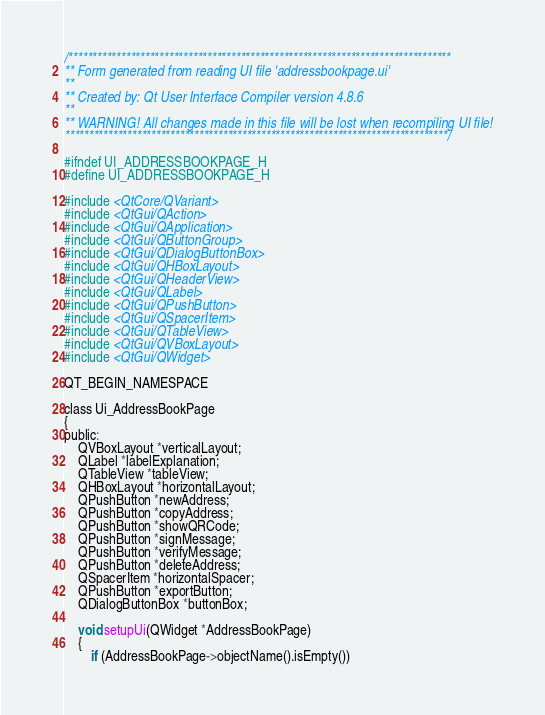<code> <loc_0><loc_0><loc_500><loc_500><_C_>/********************************************************************************
** Form generated from reading UI file 'addressbookpage.ui'
**
** Created by: Qt User Interface Compiler version 4.8.6
**
** WARNING! All changes made in this file will be lost when recompiling UI file!
********************************************************************************/

#ifndef UI_ADDRESSBOOKPAGE_H
#define UI_ADDRESSBOOKPAGE_H

#include <QtCore/QVariant>
#include <QtGui/QAction>
#include <QtGui/QApplication>
#include <QtGui/QButtonGroup>
#include <QtGui/QDialogButtonBox>
#include <QtGui/QHBoxLayout>
#include <QtGui/QHeaderView>
#include <QtGui/QLabel>
#include <QtGui/QPushButton>
#include <QtGui/QSpacerItem>
#include <QtGui/QTableView>
#include <QtGui/QVBoxLayout>
#include <QtGui/QWidget>

QT_BEGIN_NAMESPACE

class Ui_AddressBookPage
{
public:
    QVBoxLayout *verticalLayout;
    QLabel *labelExplanation;
    QTableView *tableView;
    QHBoxLayout *horizontalLayout;
    QPushButton *newAddress;
    QPushButton *copyAddress;
    QPushButton *showQRCode;
    QPushButton *signMessage;
    QPushButton *verifyMessage;
    QPushButton *deleteAddress;
    QSpacerItem *horizontalSpacer;
    QPushButton *exportButton;
    QDialogButtonBox *buttonBox;

    void setupUi(QWidget *AddressBookPage)
    {
        if (AddressBookPage->objectName().isEmpty())</code> 